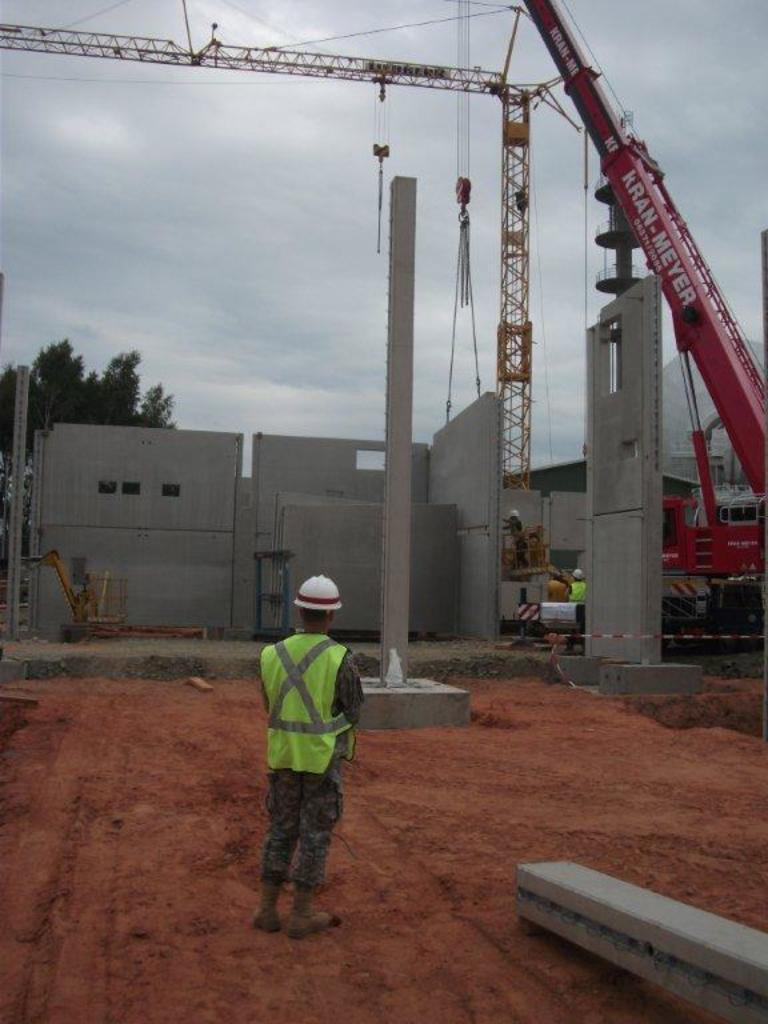Could you give a brief overview of what you see in this image? In the middle of the image a man is standing. Behind him there is a wall and there are some poles. Top right side of the image there is a crane. Top left side of the image there are some trees. Behind the trees there are some clouds and sky. 